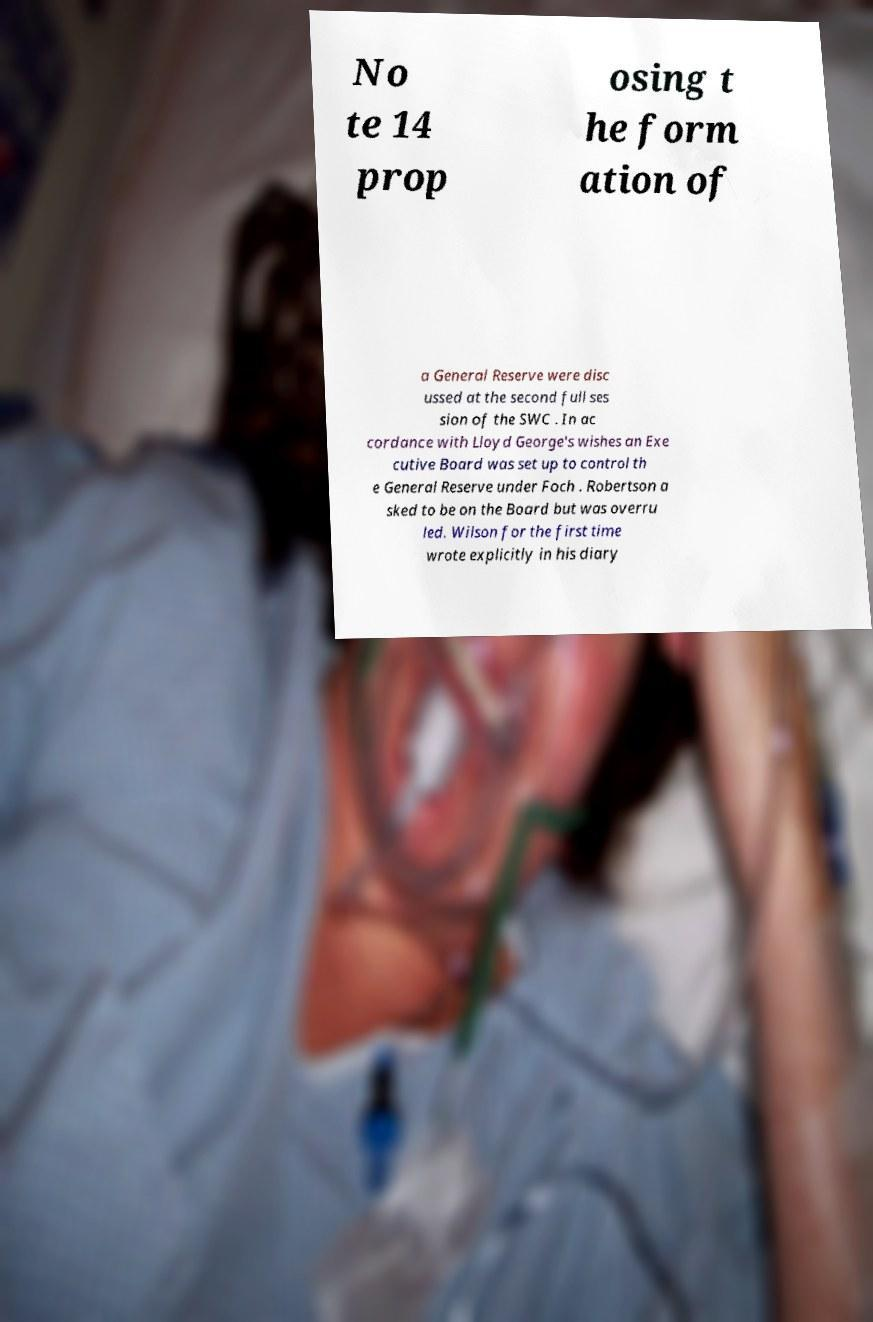Please read and relay the text visible in this image. What does it say? No te 14 prop osing t he form ation of a General Reserve were disc ussed at the second full ses sion of the SWC . In ac cordance with Lloyd George's wishes an Exe cutive Board was set up to control th e General Reserve under Foch . Robertson a sked to be on the Board but was overru led. Wilson for the first time wrote explicitly in his diary 